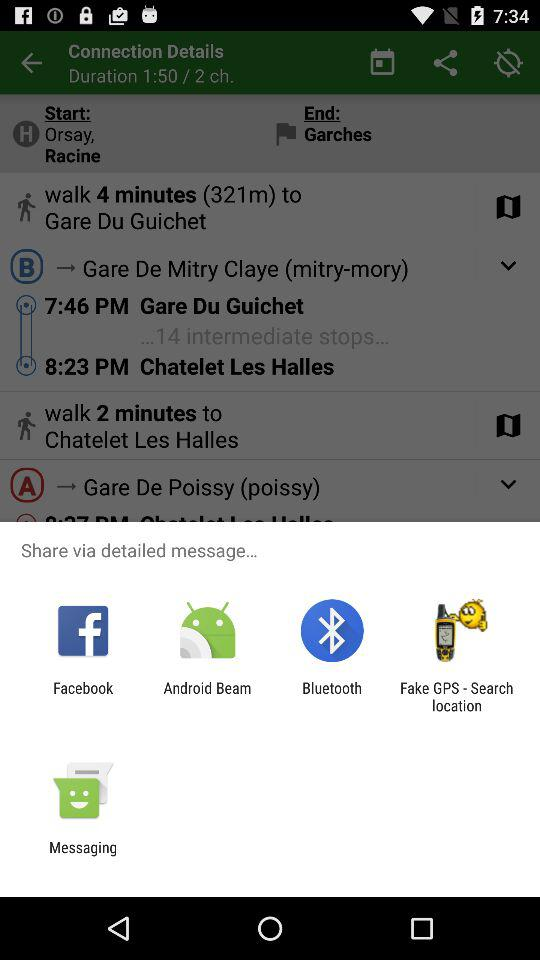What are the options to share? The options to share are "Facebook", "Android Beam", "Bluetooth", "Fake GPS - Search location" and "Messaging". 